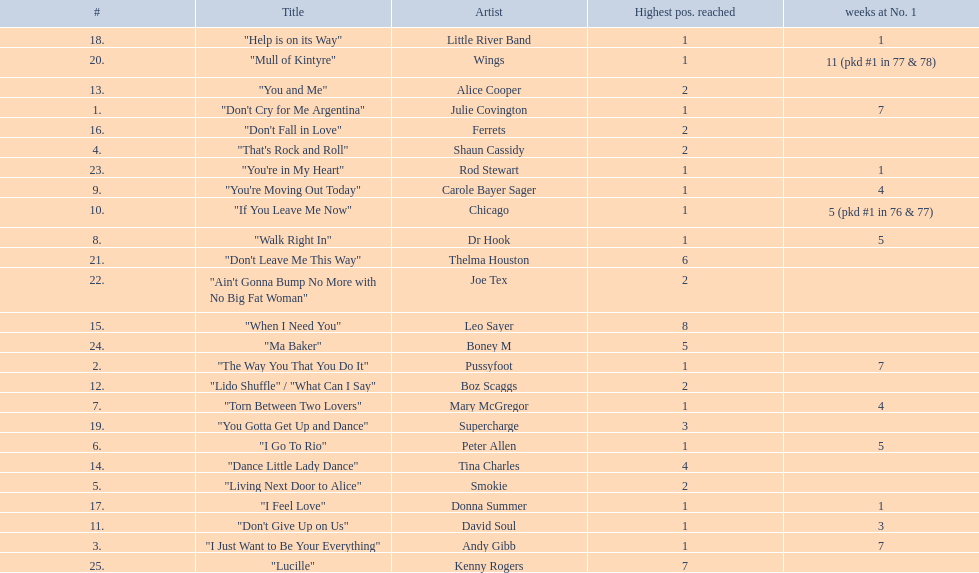Which three artists had a single at number 1 for at least 7 weeks on the australian singles charts in 1977? Julie Covington, Pussyfoot, Andy Gibb. 